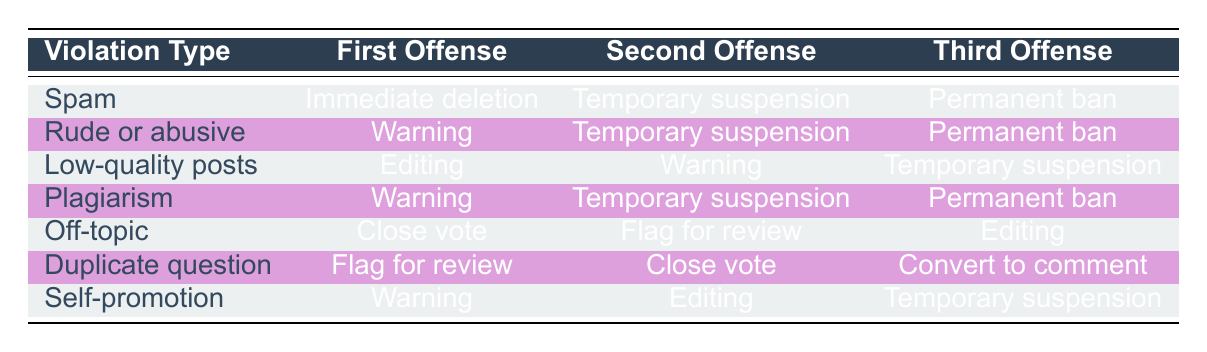What is the action for the first offense of Rude or abusive? The table shows that for the violation type "Rude or abusive," the action for the first offense is "Warning." This information is retrieved directly from the table without needing additional calculations or reasoning.
Answer: Warning How many violations result in a Permanent ban? By reviewing the table, we can see three violation types that lead to a Permanent ban: "Spam," "Rude or abusive," and "Plagiarism." Therefore, the count of violations resulting in a Permanent ban is 3.
Answer: 3 Is the action for the second offense of Low-quality posts Editing? Looking at the table, the second offense for "Low-quality posts" is listed as "Warning." Since the statement we are verifying is false, the answer is no.
Answer: No For which violation type is the first offense a Close vote? The table shows that for the violation type "Off-topic," the action for the first offense is "Close vote." No calculations are necessary here, as this is directly stated in the table.
Answer: Off-topic What is the average number of actions taken for the first offenses across all violation types? Each violation type has one action for the first offense. There are 7 violation types, each with one first offense action, resulting in a total of 7 actions. The average is calculated as the total number of actions divided by the number of violation types: 7/7 = 1.
Answer: 1 Which violation type has the most severe third offense action? To determine this, we need to look at the third offense actions for each violation type and compare their severity. The "Permanent ban" is the most severe action listed in the table and applies to "Spam," "Rude or abusive," and "Plagiarism." Therefore, any of those three have the most severe action, but to answer the question, we can simply state the first one we encounter: "Spam."
Answer: Spam Is there a distinction in actions for Low-quality posts compared to Duplicate question after the second offense? The table lists the second offense for "Low-quality posts" as "Warning" and for "Duplicate question" as "Close vote." Since these actions differ, we can conclude that there is indeed a distinction.
Answer: Yes What is the action for the third offense of Self-promotion? According to the table, for the violation type "Self-promotion," the action for the third offense is "Temporary suspension." Thus, this information is retrieved directly from the table.
Answer: Temporary suspension 